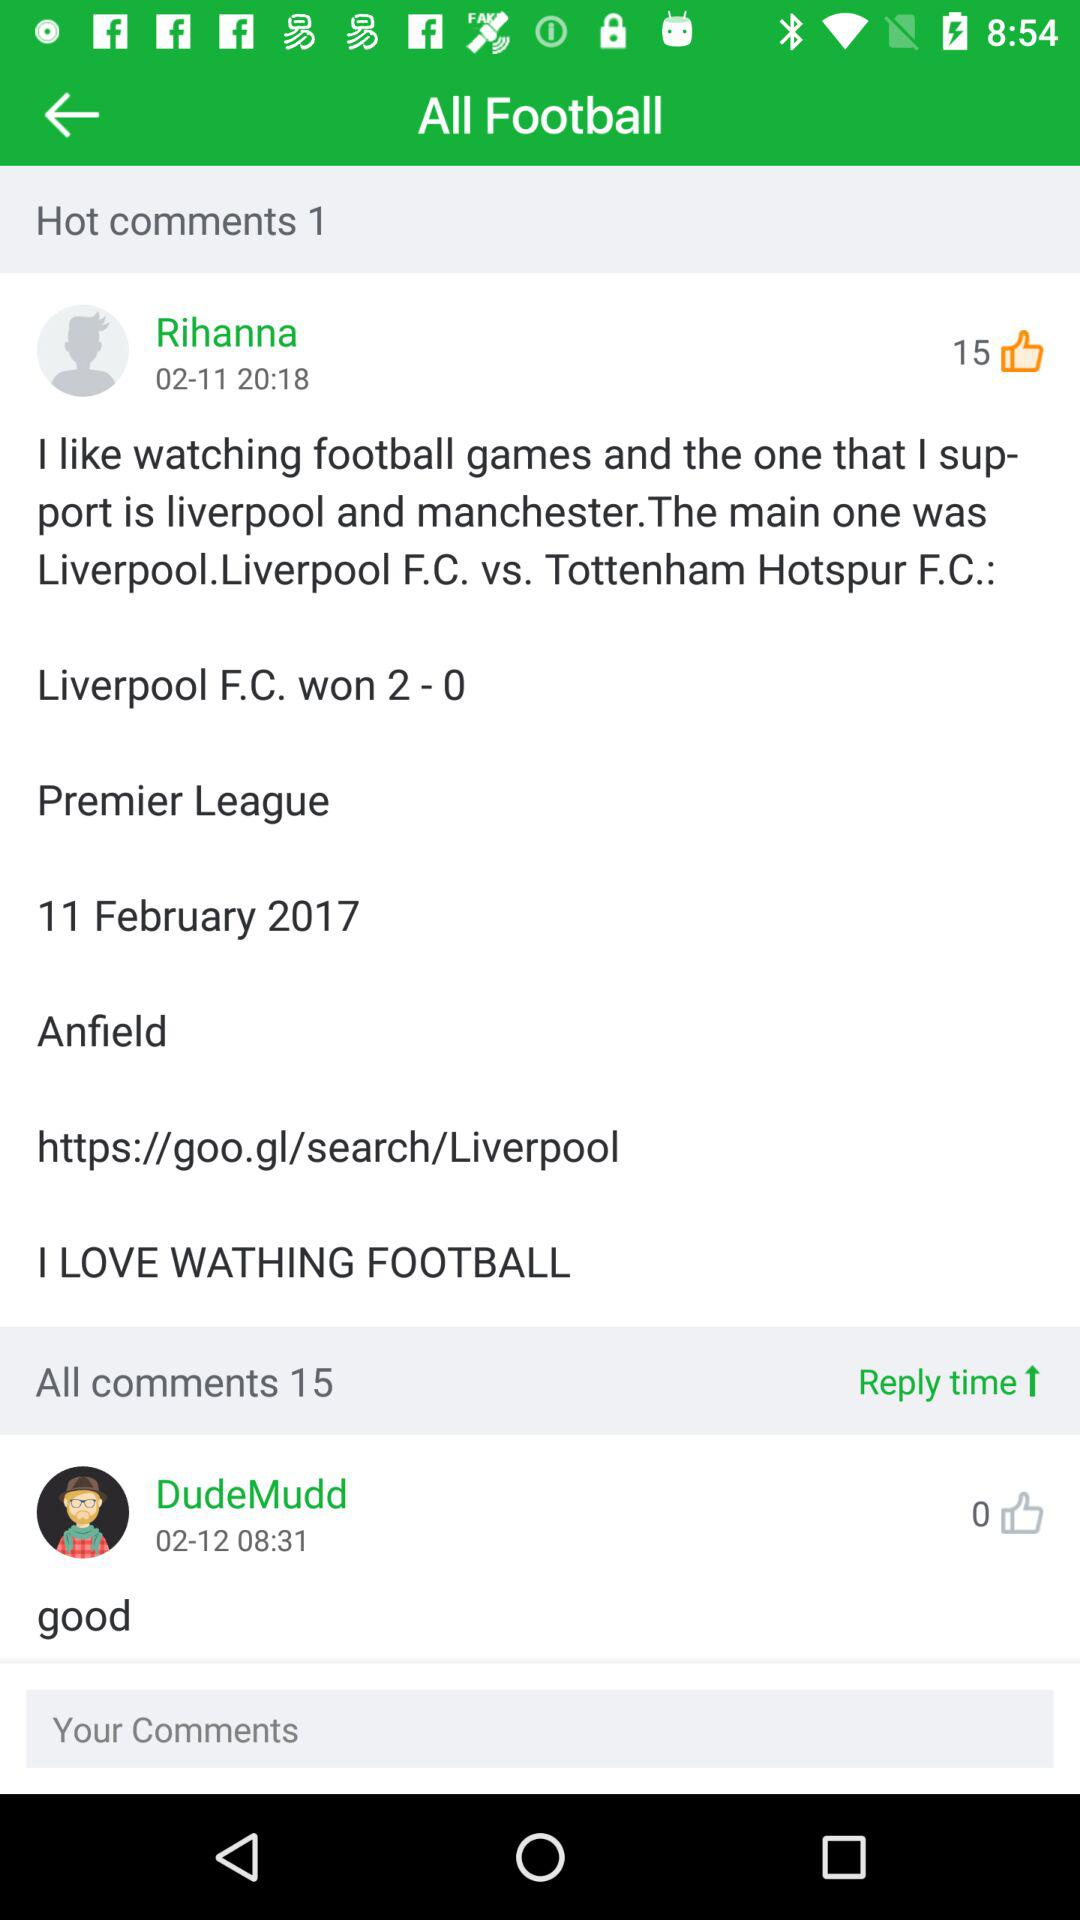How many hot comments are there? There is 1 hot comment. 